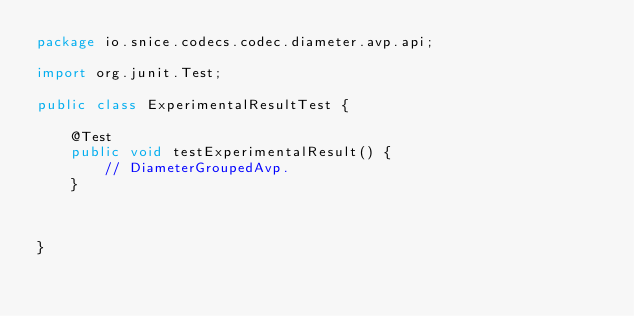Convert code to text. <code><loc_0><loc_0><loc_500><loc_500><_Java_>package io.snice.codecs.codec.diameter.avp.api;

import org.junit.Test;

public class ExperimentalResultTest {

    @Test
    public void testExperimentalResult() {
        // DiameterGroupedAvp.
    }



}</code> 